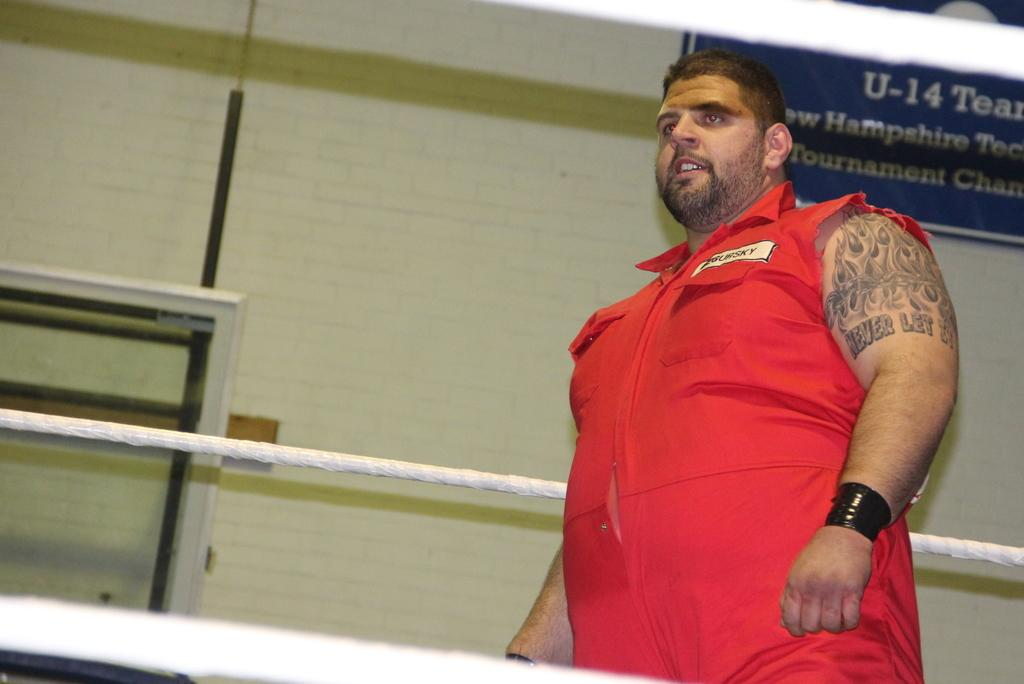Provide a one-sentence caption for the provided image. A blue sign reading U-14 Team hangs on the wall behind a burly man dressed in orange. 